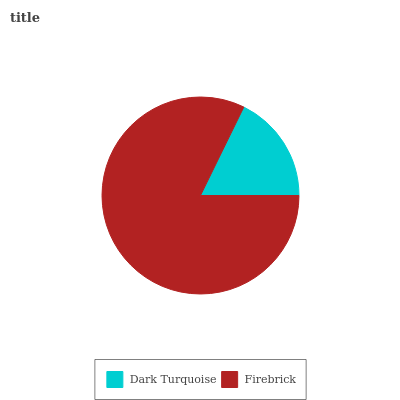Is Dark Turquoise the minimum?
Answer yes or no. Yes. Is Firebrick the maximum?
Answer yes or no. Yes. Is Firebrick the minimum?
Answer yes or no. No. Is Firebrick greater than Dark Turquoise?
Answer yes or no. Yes. Is Dark Turquoise less than Firebrick?
Answer yes or no. Yes. Is Dark Turquoise greater than Firebrick?
Answer yes or no. No. Is Firebrick less than Dark Turquoise?
Answer yes or no. No. Is Firebrick the high median?
Answer yes or no. Yes. Is Dark Turquoise the low median?
Answer yes or no. Yes. Is Dark Turquoise the high median?
Answer yes or no. No. Is Firebrick the low median?
Answer yes or no. No. 